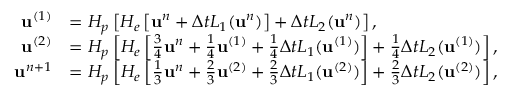<formula> <loc_0><loc_0><loc_500><loc_500>\begin{array} { r l } { u ^ { ( 1 ) } } & { = H _ { p } \left [ H _ { e } \left [ u ^ { n } + \Delta t L _ { 1 } ( u ^ { n } ) \right ] + \Delta t L _ { 2 } ( u ^ { n } ) \right ] , } \\ { u ^ { ( 2 ) } } & { = H _ { p } \left [ H _ { e } \left [ \frac { 3 } { 4 } u ^ { n } + \frac { 1 } { 4 } u ^ { ( 1 ) } + \frac { 1 } { 4 } \Delta t L _ { 1 } ( u ^ { ( 1 ) } ) \right ] + \frac { 1 } { 4 } \Delta t L _ { 2 } ( u ^ { ( 1 ) } ) \right ] , } \\ { u ^ { n + 1 } } & { = H _ { p } \left [ H _ { e } \left [ \frac { 1 } { 3 } u ^ { n } + \frac { 2 } { 3 } u ^ { ( 2 ) } + \frac { 2 } { 3 } \Delta t L _ { 1 } ( u ^ { ( 2 ) } ) \right ] + \frac { 2 } { 3 } \Delta t L _ { 2 } ( u ^ { ( 2 ) } ) \right ] , } \end{array}</formula> 